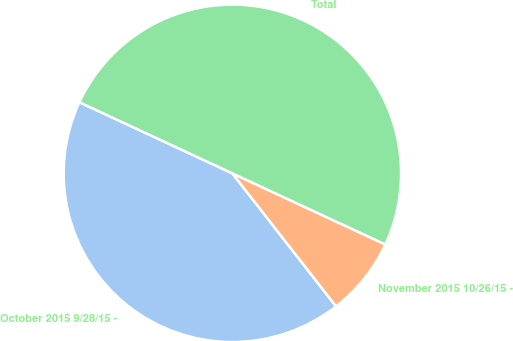Convert chart. <chart><loc_0><loc_0><loc_500><loc_500><pie_chart><fcel>October 2015 9/28/15 -<fcel>November 2015 10/26/15 -<fcel>Total<nl><fcel>42.46%<fcel>7.54%<fcel>50.0%<nl></chart> 